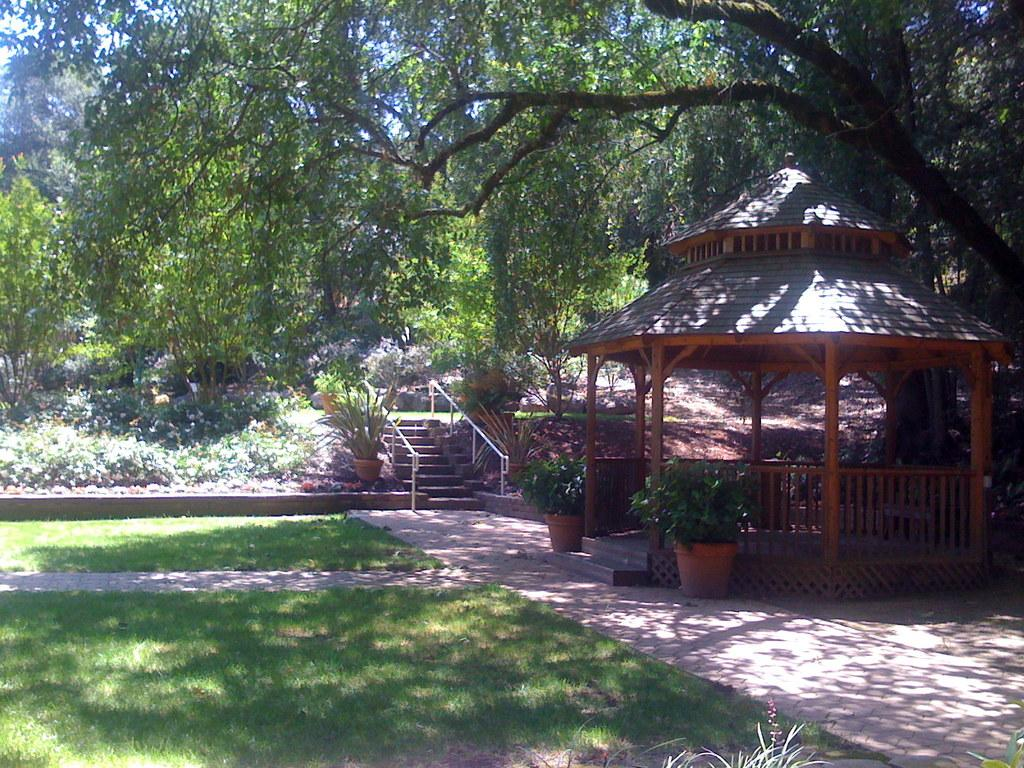What type of vegetation is present on the ground in the image? There is grass on the ground in the image. What other types of plants can be seen in the image? There are house plants in the image. What type of structure is visible in the image? There is a shed in the image. What architectural feature is present in the image? There are steps in the image. What can be seen in the background of the image? There are trees and the sky visible in the background of the image. How many friends are sitting on the pancake in the image? There is no pancake or friends present in the image. What type of boundary is visible in the image? There is no boundary visible in the image. 